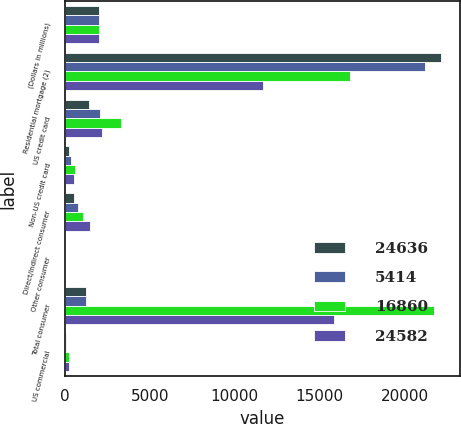Convert chart. <chart><loc_0><loc_0><loc_500><loc_500><stacked_bar_chart><ecel><fcel>(Dollars in millions)<fcel>Residential mortgage (2)<fcel>US credit card<fcel>Non-US credit card<fcel>Direct/Indirect consumer<fcel>Other consumer<fcel>Total consumer<fcel>US commercial<nl><fcel>24636<fcel>2012<fcel>22157<fcel>1437<fcel>212<fcel>545<fcel>2<fcel>1247.5<fcel>65<nl><fcel>5414<fcel>2011<fcel>21164<fcel>2070<fcel>342<fcel>746<fcel>2<fcel>1247.5<fcel>75<nl><fcel>16860<fcel>2010<fcel>16768<fcel>3320<fcel>599<fcel>1058<fcel>2<fcel>21747<fcel>236<nl><fcel>24582<fcel>2009<fcel>11680<fcel>2158<fcel>515<fcel>1488<fcel>3<fcel>15844<fcel>213<nl></chart> 